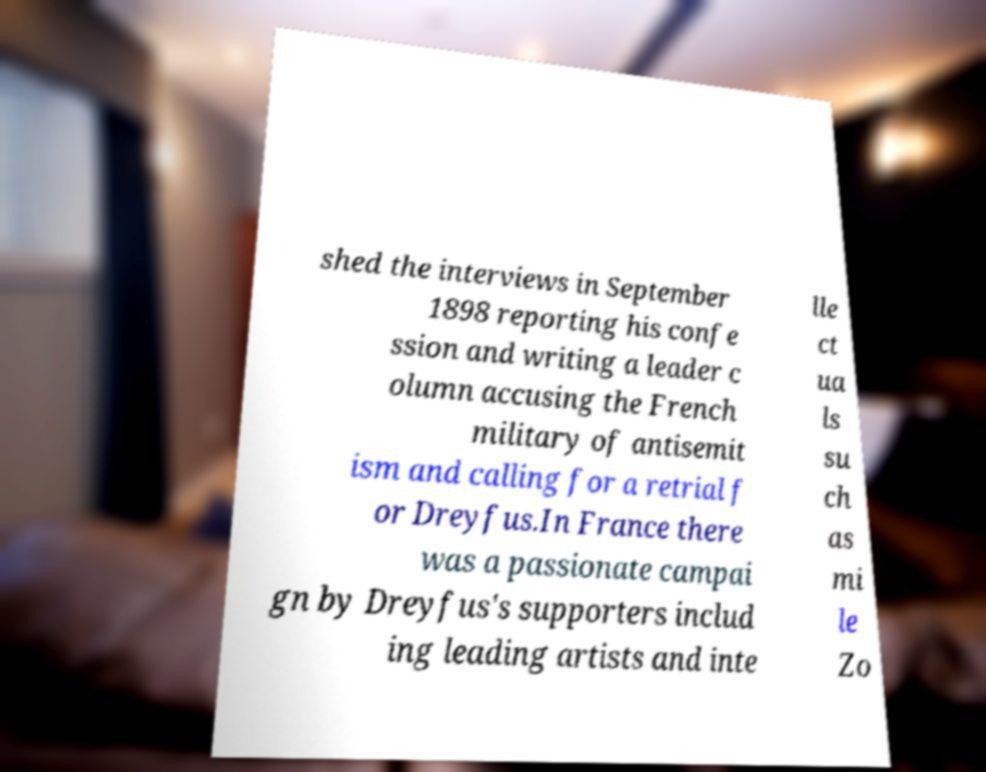Can you read and provide the text displayed in the image?This photo seems to have some interesting text. Can you extract and type it out for me? shed the interviews in September 1898 reporting his confe ssion and writing a leader c olumn accusing the French military of antisemit ism and calling for a retrial f or Dreyfus.In France there was a passionate campai gn by Dreyfus's supporters includ ing leading artists and inte lle ct ua ls su ch as mi le Zo 